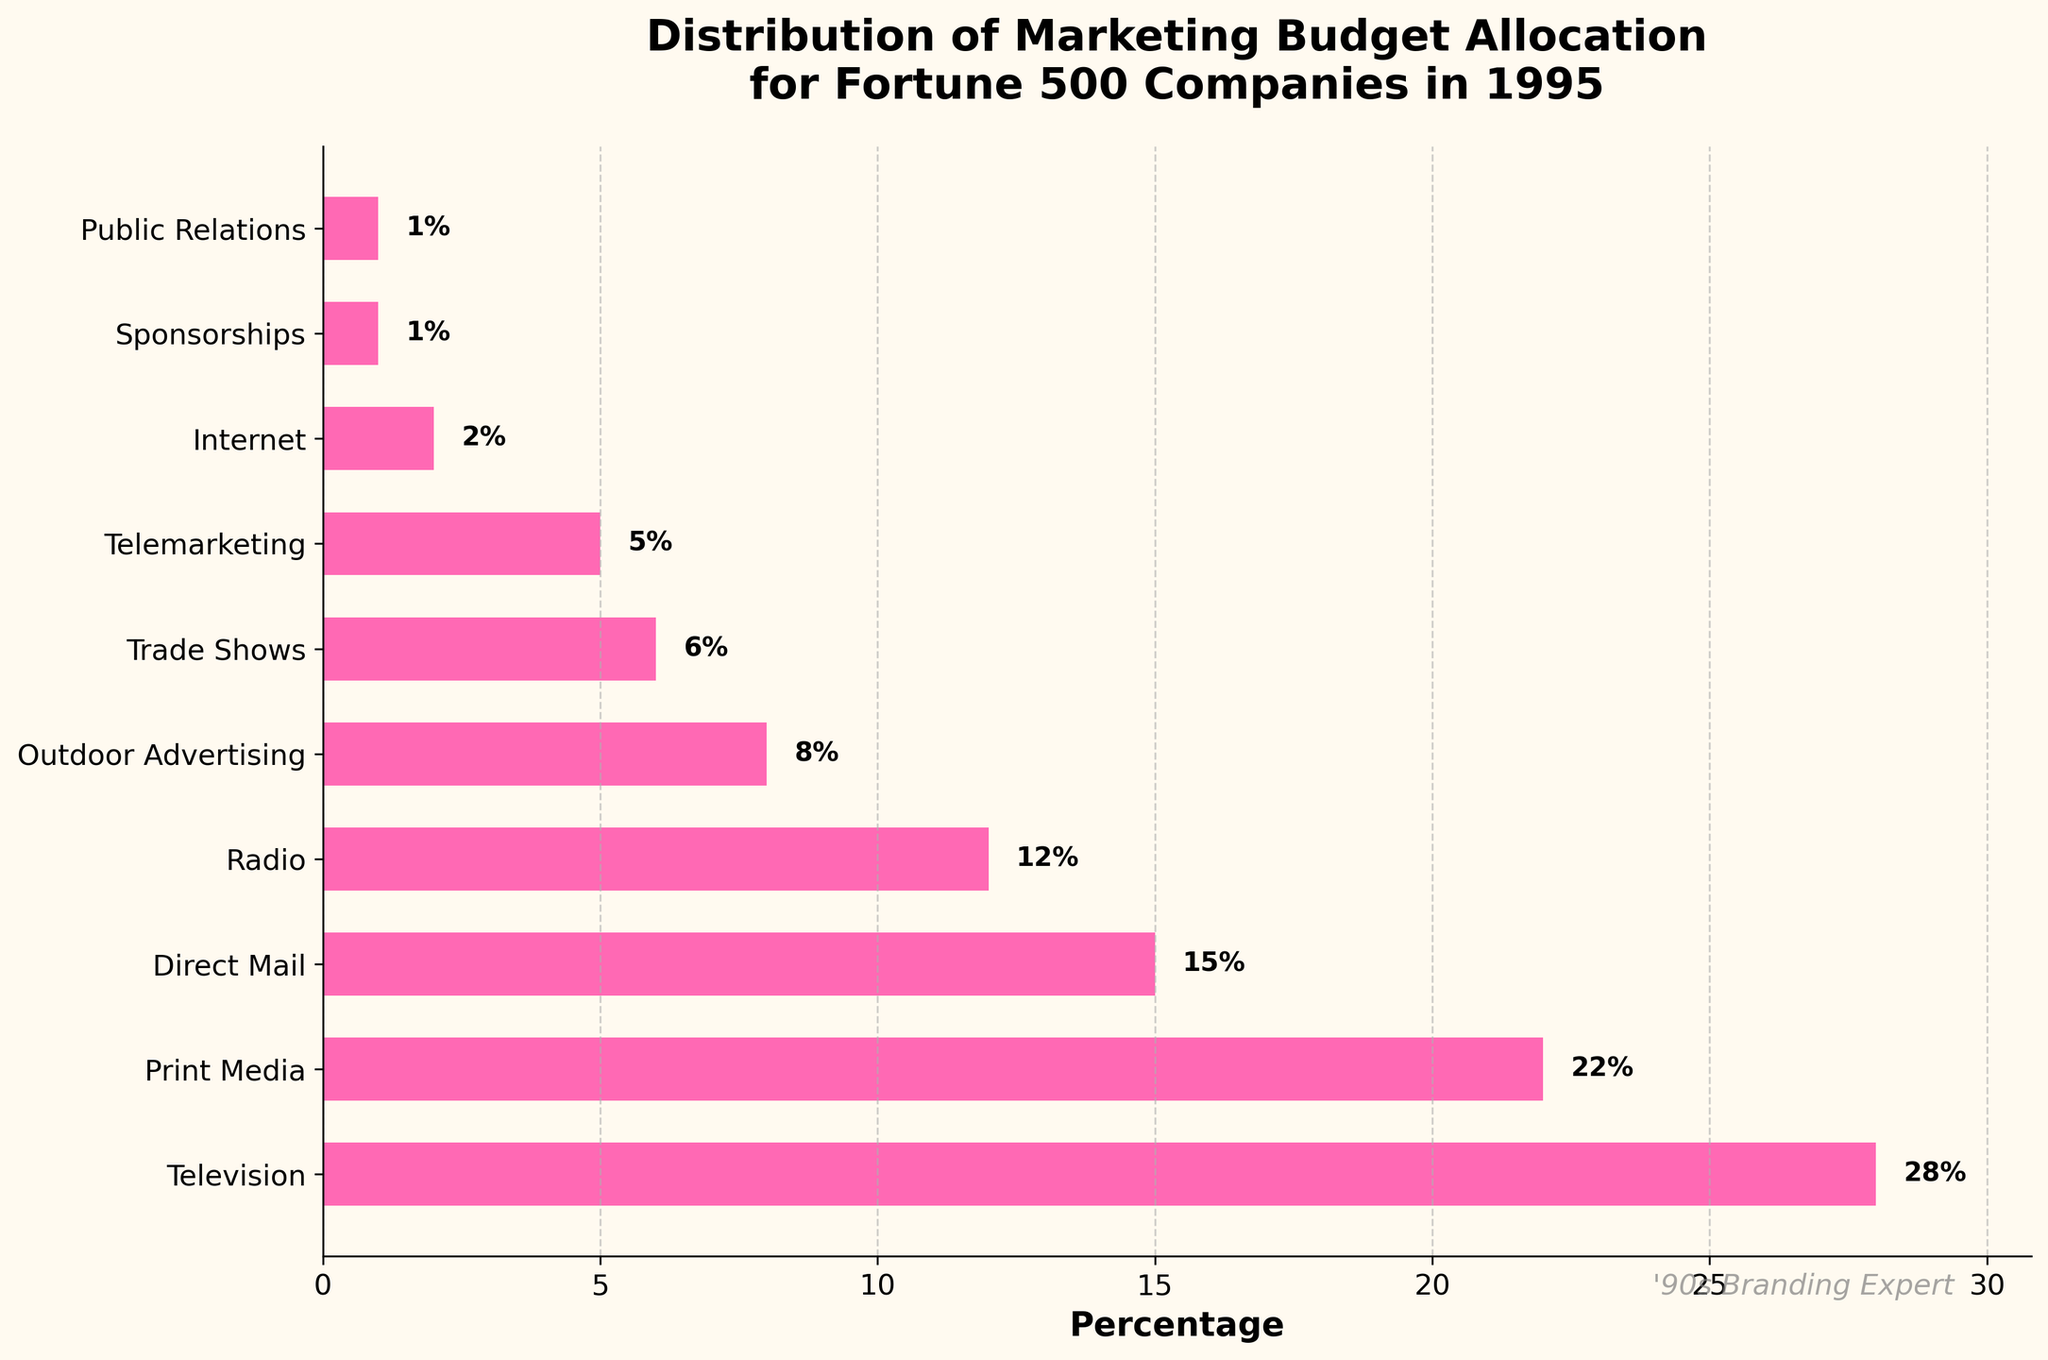What percentage of the marketing budget was allocated to internet advertising in 1995? The bar corresponding to "Internet" shows a percentage of 2%.
Answer: 2% Which category received the highest marketing budget allocation in 1995? The bar representing "Television" is the longest, indicating the highest percentage of 28%.
Answer: Television What is the combined percentage of the budget for Print Media and Radio? The percentage for Print Media is 22% and for Radio is 12%. Adding these together: 22% + 12% = 34%.
Answer: 34% Which categories each received a budget allocation of less than or equal to 5%? The categories with budget allocations of 5% or less are "Telemarketing" (5%), "Internet" (2%), "Sponsorships" (1%), and "Public Relations" (1%).
Answer: Telemarketing, Internet, Sponsorships, Public Relations How much more budget was allocated to Television than to Outdoor Advertising? The budget for Television is 28% and for Outdoor Advertising is 8%. The difference is 28% - 8% = 20%.
Answer: 20% Compare the allocations of Direct Mail and Trade Shows. Which one received a higher percentage and by how much? Direct Mail has a budget of 15% and Trade Shows have 6%. The difference is 15% - 6% = 9%. Direct Mail received a higher percentage.
Answer: Direct Mail, 9% What is the average budget allocation percentage across all categories? Sum all percentages: 28% + 22% + 15% + 12% + 8% + 6% + 5% + 2% + 1% + 1% = 100%. There are 10 categories, so the average is 100% / 10 = 10%.
Answer: 10% What percentage of the budget was allocated to categories besides Television and Print Media? Total budget percentage allocated to Television and Print Media is 28% + 22% = 50%. The remaining budget is 100% - 50% = 50%.
Answer: 50% Among the categories listed, identify one where the budget percentage is exactly half of Print Media. Print Media has a budget of 22%. Half of this is 22% / 2 = 11%. The category closest to this value is Radio at 12%. (Note: Exact half is not present; closest category is provided.)
Answer: Radio 